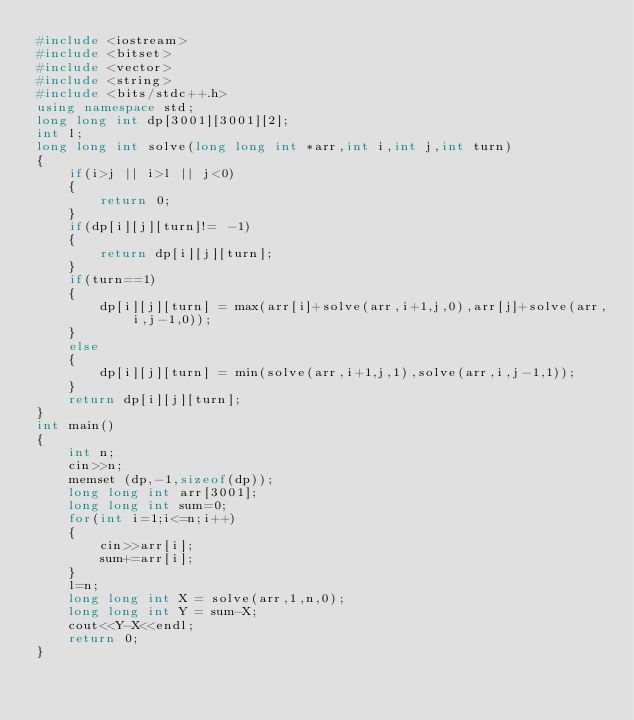Convert code to text. <code><loc_0><loc_0><loc_500><loc_500><_C++_>#include <iostream>
#include <bitset>
#include <vector>
#include <string>
#include <bits/stdc++.h>
using namespace std;
long long int dp[3001][3001][2];
int l;
long long int solve(long long int *arr,int i,int j,int turn)
{
    if(i>j || i>l || j<0)
    {
        return 0;
    }
    if(dp[i][j][turn]!= -1)
    {
        return dp[i][j][turn];
    }
    if(turn==1)
    {
        dp[i][j][turn] = max(arr[i]+solve(arr,i+1,j,0),arr[j]+solve(arr,i,j-1,0));
    }
    else
    {
        dp[i][j][turn] = min(solve(arr,i+1,j,1),solve(arr,i,j-1,1));
    }
    return dp[i][j][turn];
}
int main()
{
    int n;
    cin>>n;
    memset (dp,-1,sizeof(dp));
    long long int arr[3001];
    long long int sum=0;
    for(int i=1;i<=n;i++)
    {
        cin>>arr[i];
        sum+=arr[i];
    }
    l=n;
    long long int X = solve(arr,1,n,0);
    long long int Y = sum-X;
    cout<<Y-X<<endl;
    return 0;
}
</code> 